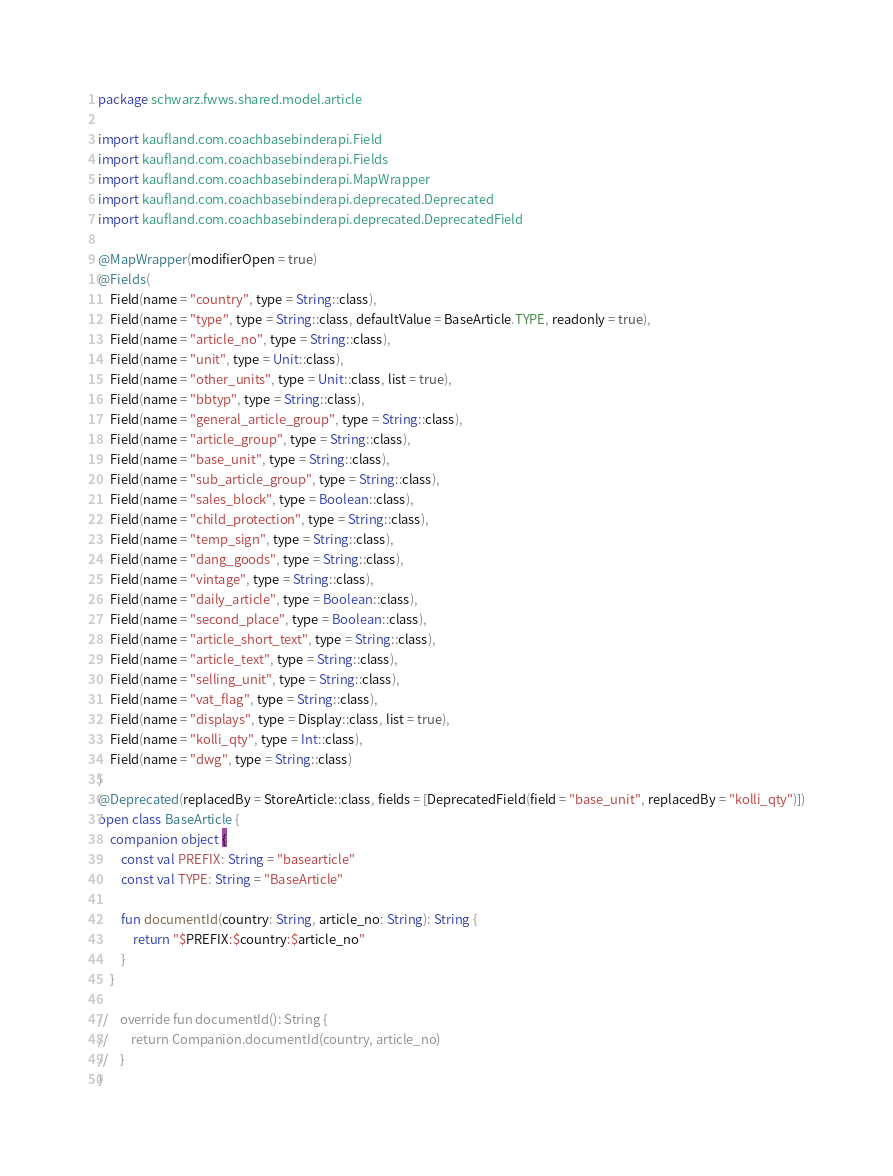<code> <loc_0><loc_0><loc_500><loc_500><_Kotlin_>package schwarz.fwws.shared.model.article

import kaufland.com.coachbasebinderapi.Field
import kaufland.com.coachbasebinderapi.Fields
import kaufland.com.coachbasebinderapi.MapWrapper
import kaufland.com.coachbasebinderapi.deprecated.Deprecated
import kaufland.com.coachbasebinderapi.deprecated.DeprecatedField

@MapWrapper(modifierOpen = true)
@Fields(
    Field(name = "country", type = String::class),
    Field(name = "type", type = String::class, defaultValue = BaseArticle.TYPE, readonly = true),
    Field(name = "article_no", type = String::class),
    Field(name = "unit", type = Unit::class),
    Field(name = "other_units", type = Unit::class, list = true),
    Field(name = "bbtyp", type = String::class),
    Field(name = "general_article_group", type = String::class),
    Field(name = "article_group", type = String::class),
    Field(name = "base_unit", type = String::class),
    Field(name = "sub_article_group", type = String::class),
    Field(name = "sales_block", type = Boolean::class),
    Field(name = "child_protection", type = String::class),
    Field(name = "temp_sign", type = String::class),
    Field(name = "dang_goods", type = String::class),
    Field(name = "vintage", type = String::class),
    Field(name = "daily_article", type = Boolean::class),
    Field(name = "second_place", type = Boolean::class),
    Field(name = "article_short_text", type = String::class),
    Field(name = "article_text", type = String::class),
    Field(name = "selling_unit", type = String::class),
    Field(name = "vat_flag", type = String::class),
    Field(name = "displays", type = Display::class, list = true),
    Field(name = "kolli_qty", type = Int::class),
    Field(name = "dwg", type = String::class)
)
@Deprecated(replacedBy = StoreArticle::class, fields = [DeprecatedField(field = "base_unit", replacedBy = "kolli_qty")])
open class BaseArticle {
    companion object {
        const val PREFIX: String = "basearticle"
        const val TYPE: String = "BaseArticle"

        fun documentId(country: String, article_no: String): String {
            return "$PREFIX:$country:$article_no"
        }
    }

//    override fun documentId(): String {
//        return Companion.documentId(country, article_no)
//    }
}
</code> 